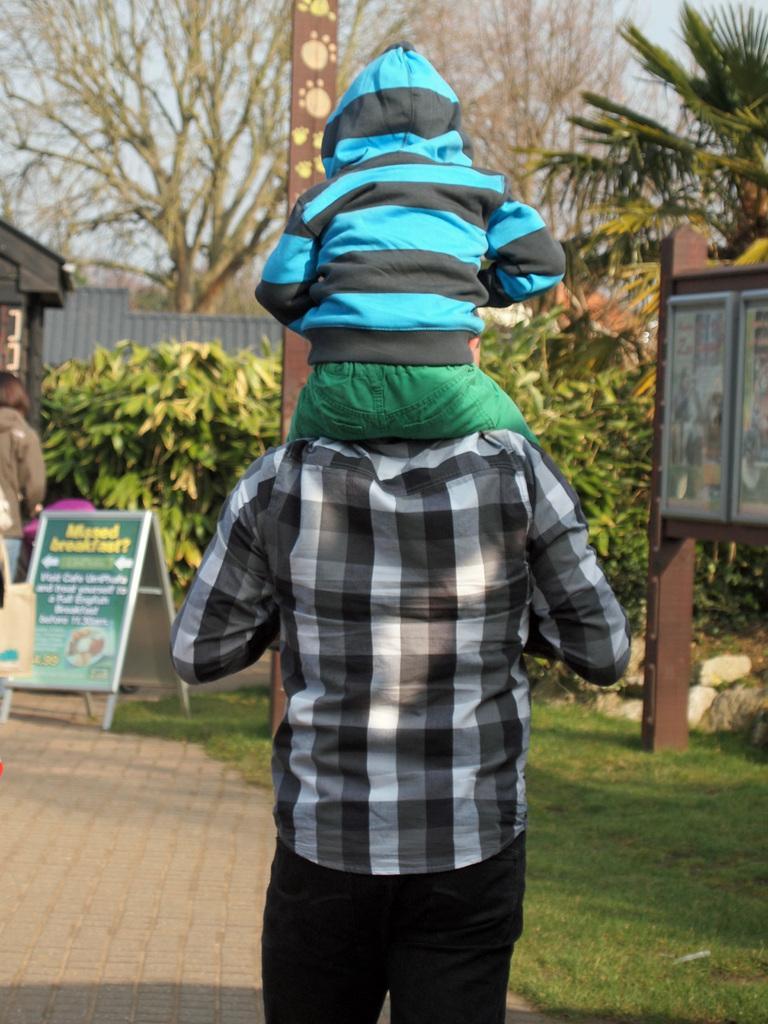Describe this image in one or two sentences. In the foreground of this image, there is a kid sitting on a man. In the background, there are boards, a person, building, trees, grass and the ground. 